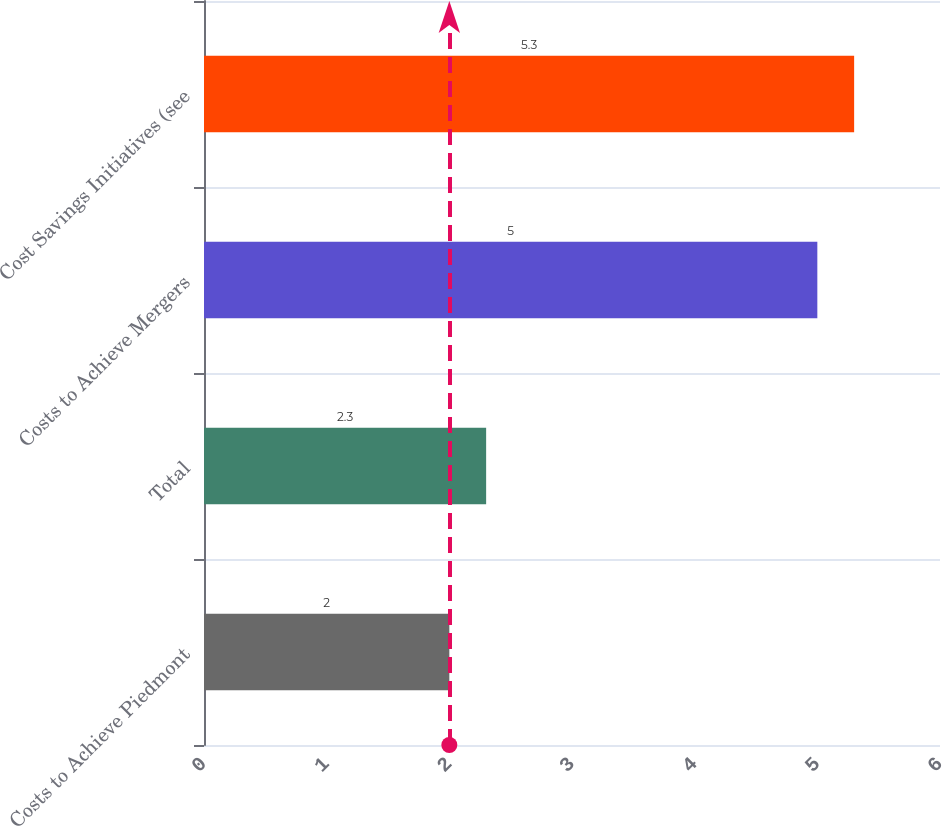Convert chart to OTSL. <chart><loc_0><loc_0><loc_500><loc_500><bar_chart><fcel>Costs to Achieve Piedmont<fcel>Total<fcel>Costs to Achieve Mergers<fcel>Cost Savings Initiatives (see<nl><fcel>2<fcel>2.3<fcel>5<fcel>5.3<nl></chart> 